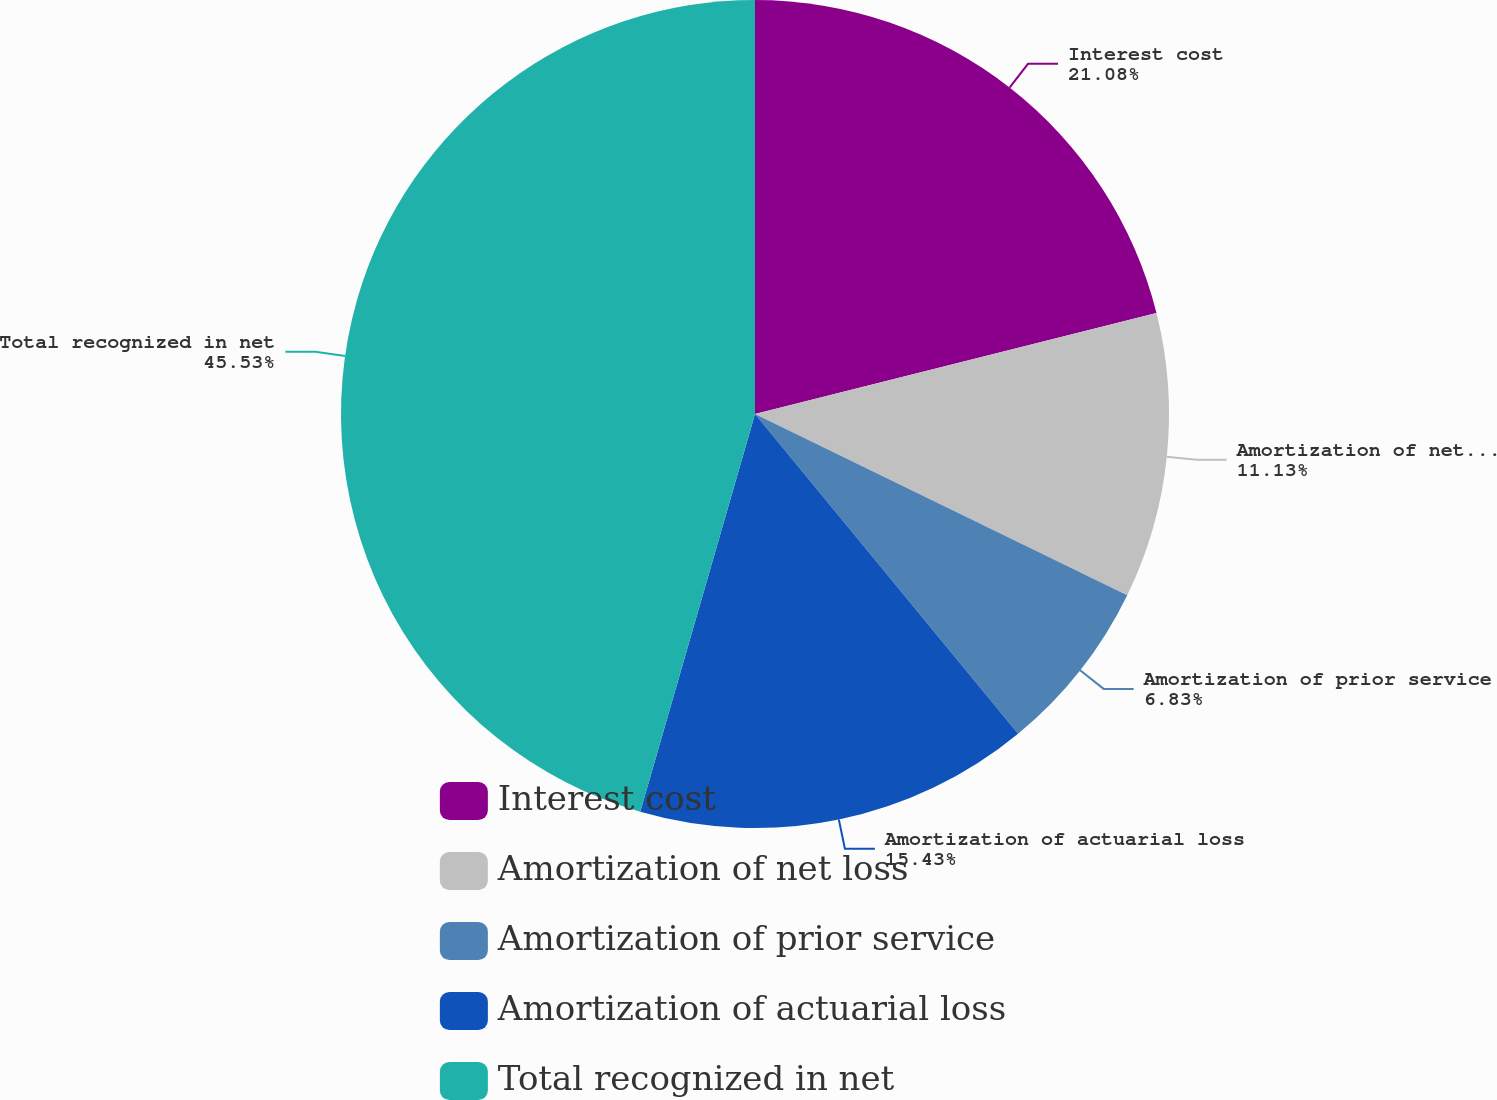Convert chart to OTSL. <chart><loc_0><loc_0><loc_500><loc_500><pie_chart><fcel>Interest cost<fcel>Amortization of net loss<fcel>Amortization of prior service<fcel>Amortization of actuarial loss<fcel>Total recognized in net<nl><fcel>21.08%<fcel>11.13%<fcel>6.83%<fcel>15.43%<fcel>45.53%<nl></chart> 